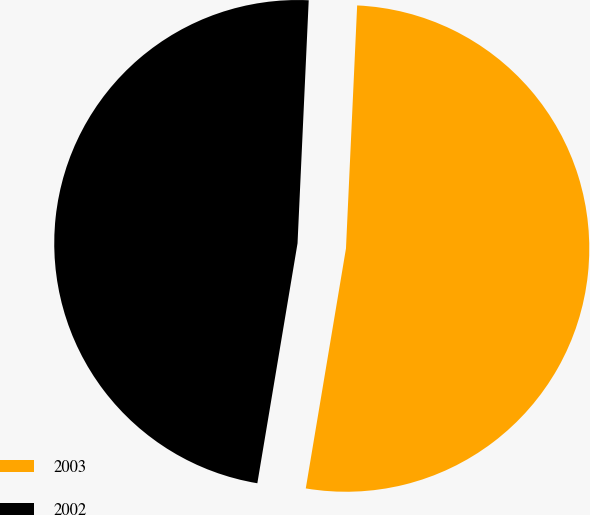<chart> <loc_0><loc_0><loc_500><loc_500><pie_chart><fcel>2003<fcel>2002<nl><fcel>51.91%<fcel>48.09%<nl></chart> 